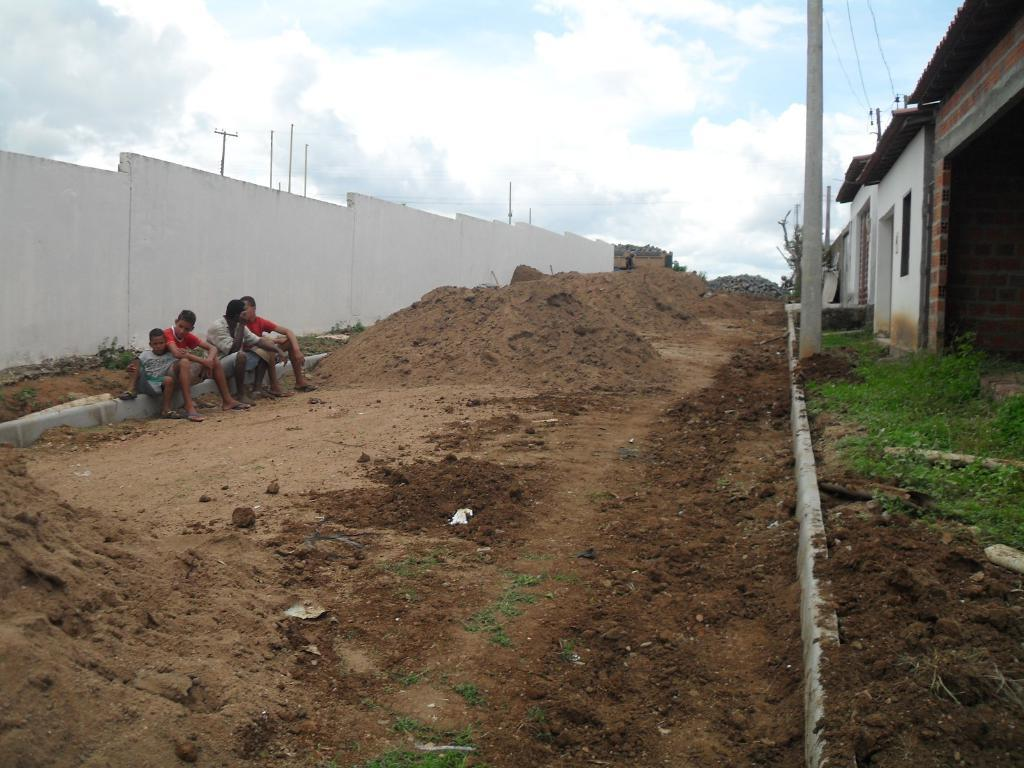What are the boys in the image doing? The boys are sitting on the ground in the image. What structures can be seen in the image? There are poles, a wall, and a shelter in the image. What type of surface are the boys sitting on? There are stones in the image, which the boys are sitting on. What can be seen in the background of the image? The sky with clouds is visible in the background of the image. What type of coal is being used to fuel the hall in the image? There is no hall or coal present in the image. How many wings can be seen on the boys in the image? The boys in the image do not have wings, as they are human. 